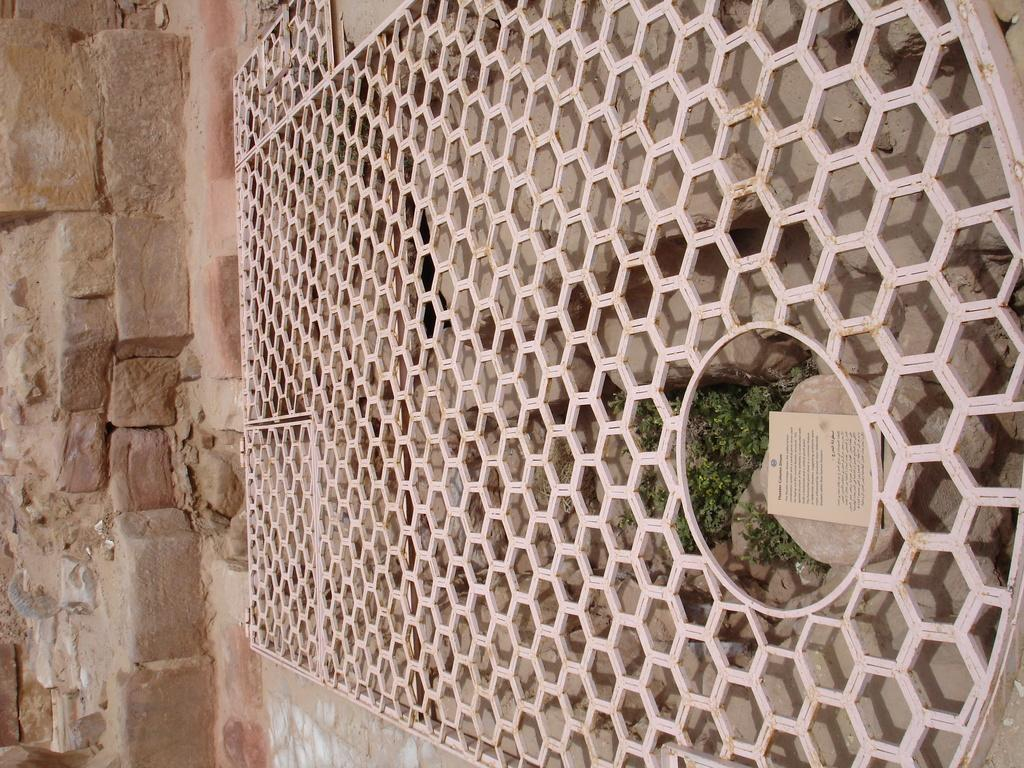What type of structure is located on the right side of the image? There is a big concrete grill on the right side of the image. What can be seen in the front of the image? There is a granite wall in the front of the image. What type of hat is the grill wearing in the image? There is no hat present in the image, as the grill is a structure and not a person or animate object. 